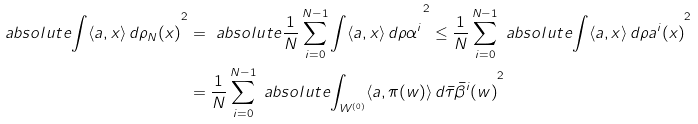Convert formula to latex. <formula><loc_0><loc_0><loc_500><loc_500>\ a b s o l u t e { \int \langle a , x \rangle \, d \rho _ { N } ( x ) } ^ { 2 } & = \ a b s o l u t e { \frac { 1 } { N } \sum _ { i = 0 } ^ { N - 1 } \int \langle a , x \rangle \, d \rho \alpha ^ { i } } ^ { 2 } \leq \frac { 1 } { N } \sum _ { i = 0 } ^ { N - 1 } \ a b s o l u t e { \int \langle a , x \rangle \, d \rho a ^ { i } ( x ) } ^ { 2 } \\ & = \frac { 1 } { N } \sum _ { i = 0 } ^ { N - 1 } \ a b s o l u t e { \int _ { W ^ { ( 0 ) } } \langle a , \pi ( w ) \rangle \, d \bar { \tau } \bar { \beta } ^ { i } ( w ) } ^ { 2 }</formula> 